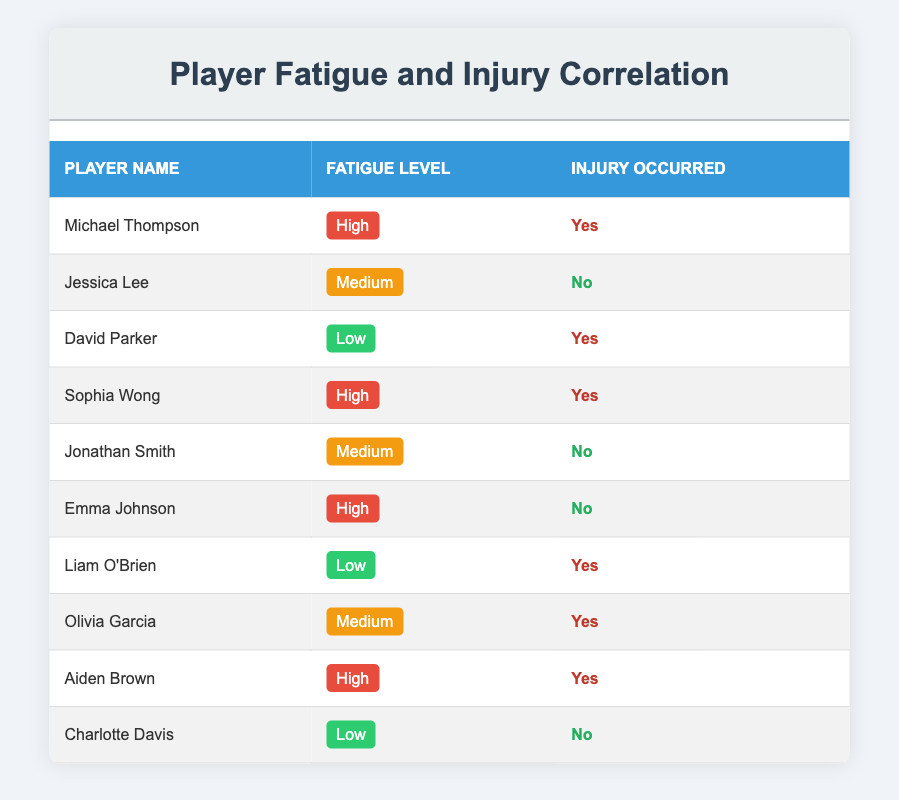What is the fatigue level of David Parker? David Parker’s row indicates that his recorded fatigue level is listed as "Low."
Answer: Low How many players experienced injuries with a fatigue level of High? The players with a fatigue level of High are Michael Thompson, Sophia Wong, and Aiden Brown. Therefore, the number of players is three.
Answer: 3 Is there a player with Medium fatigue level who also experienced an injury? Upon checking the table, Olivia Garcia is the only player with a Medium fatigue level that has a record of injury occurrence.
Answer: Yes What percentage of players with a Low fatigue level had injuries? There are three players with a Low fatigue level (David Parker, Liam O'Brien, and Charlotte Davis). Out of these, two (David Parker and Liam O'Brien) had injuries. To find the percentage, (2 injuries/3 players) * 100 equals approximately 66.67 percent.
Answer: 66.67% How many players did not experience injuries? The players who did not experience injuries are Jessica Lee, Jonathan Smith, Emma Johnson, and Charlotte Davis. This totals four players.
Answer: 4 What is the total number of players listed in the table? The table lists a total of ten players, including all recorded entries.
Answer: 10 How many players had a High fatigue level and did not sustain an injury? Only Emma Johnson had a High fatigue level and did not sustain an injury, making the total count one.
Answer: 1 What is the proportion of players with a High fatigue level? Of the ten players, five have a High fatigue level (Michael Thompson, Sophia Wong, Emma Johnson, Aiden Brown). Thus, the proportion is 5 out of 10 or 50 percent.
Answer: 50% 